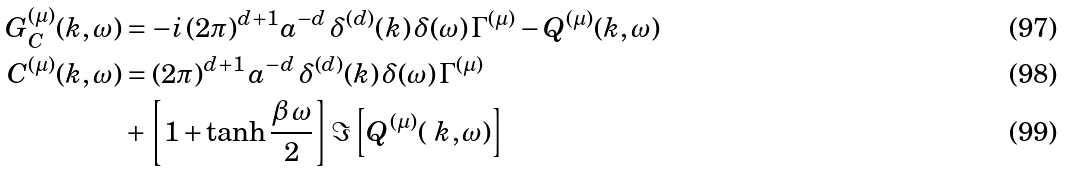Convert formula to latex. <formula><loc_0><loc_0><loc_500><loc_500>G ^ { ( \mu ) } _ { C } ( k , \omega ) & = - i \, ( 2 \pi ) ^ { d + 1 } a ^ { - d } \, \delta ^ { ( d ) } ( k ) \, \delta ( \omega ) \, \Gamma ^ { ( \mu ) } - Q ^ { ( \mu ) } ( k , \omega ) \\ C ^ { ( \mu ) } ( k , \omega ) & = ( 2 \pi ) ^ { d + 1 } \, a ^ { - d } \, \delta ^ { ( d ) } ( k ) \, \delta ( \omega ) \, \Gamma ^ { ( \mu ) } \\ & + \left [ 1 + \tanh \frac { \beta \, \omega } 2 \right ] \Im \left [ Q ^ { ( \mu ) } ( \ k , \omega ) \right ]</formula> 